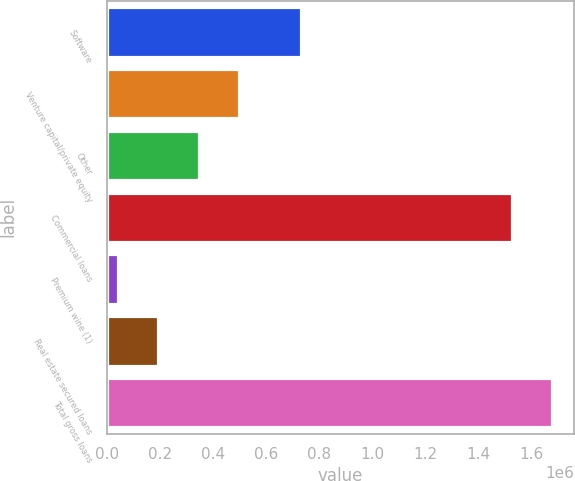<chart> <loc_0><loc_0><loc_500><loc_500><bar_chart><fcel>Software<fcel>Venture capital/private equity<fcel>Other<fcel>Commercial loans<fcel>Premium wine (1)<fcel>Real estate secured loans<fcel>Total gross loans<nl><fcel>731840<fcel>499513<fcel>347114<fcel>1.52399e+06<fcel>42316<fcel>194715<fcel>1.67639e+06<nl></chart> 